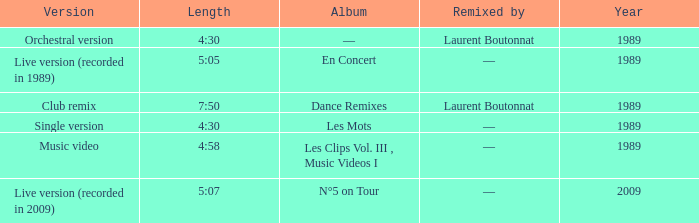Album of les mots had what lowest year? 1989.0. 